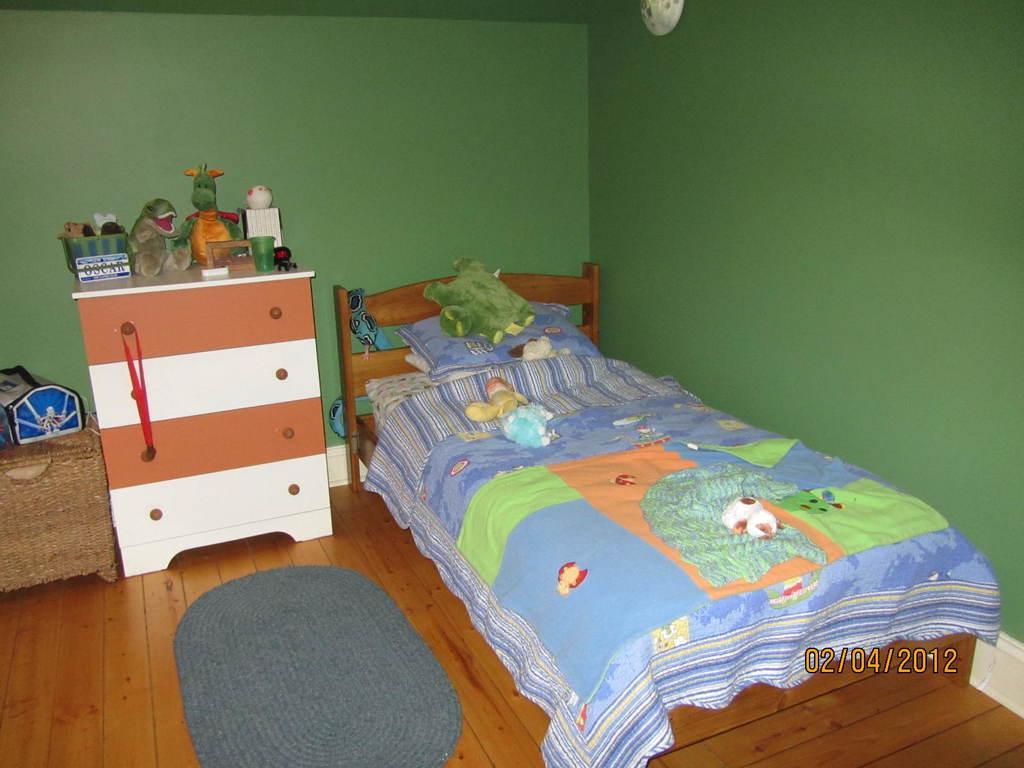In one or two sentences, can you explain what this image depicts? In this picture we can see a room with bed with pillow, toys, bed sheet on it and aside to this cupboards, medal, some toys, door mat, wall. 